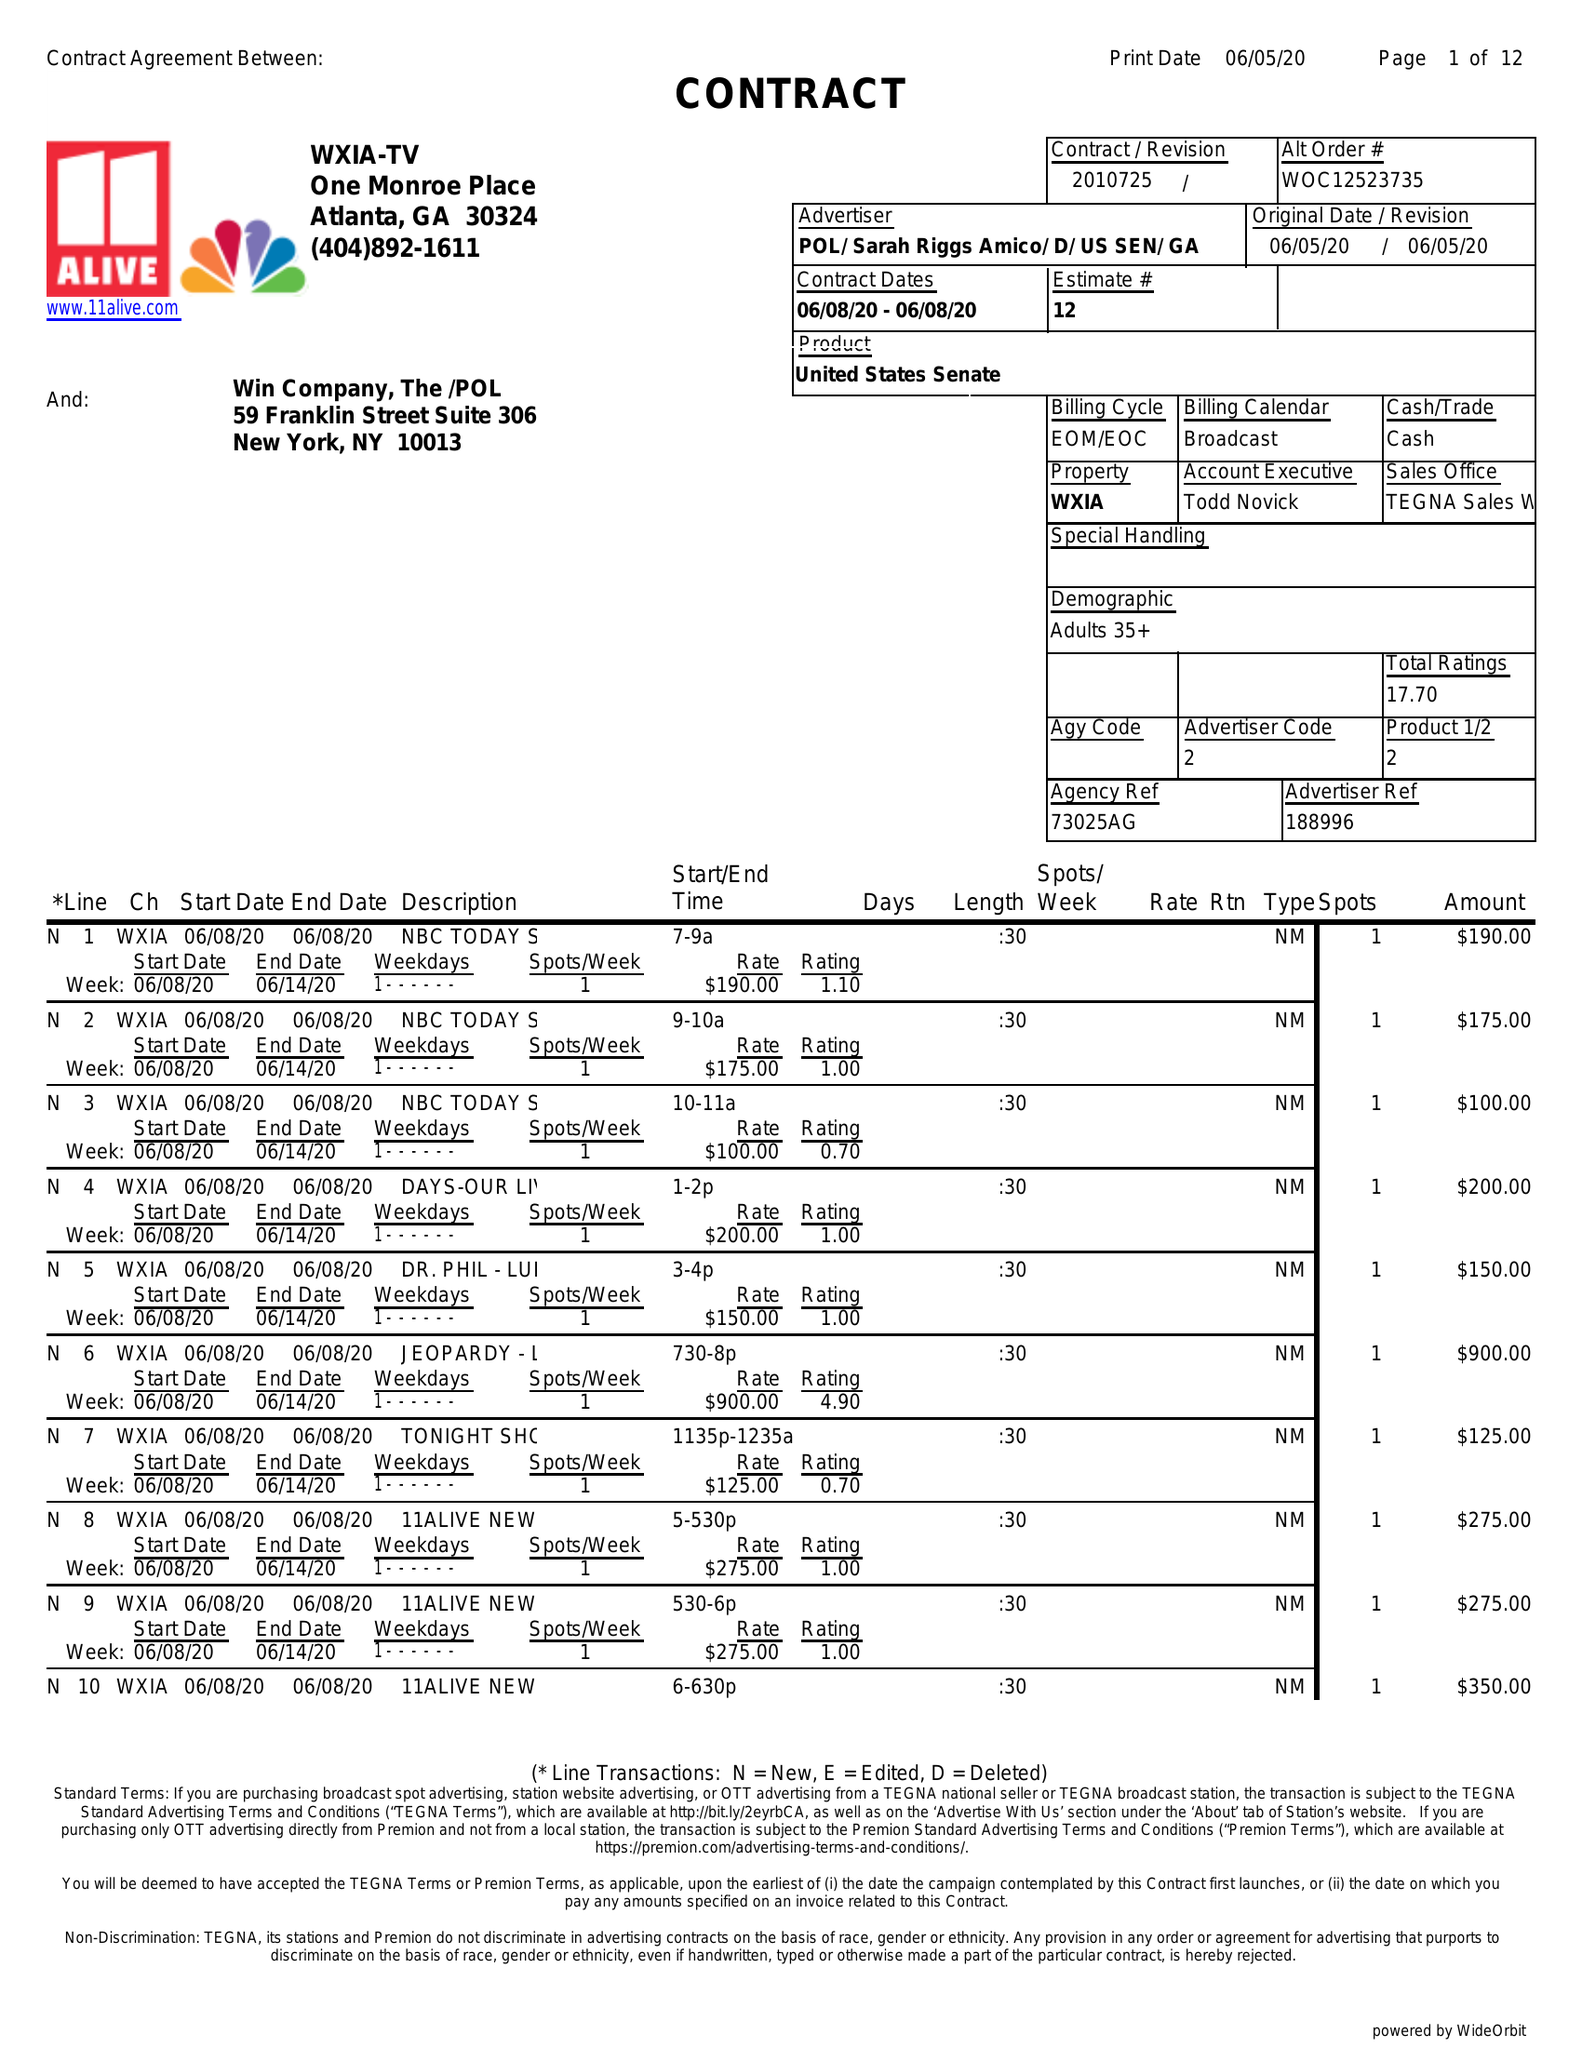What is the value for the flight_from?
Answer the question using a single word or phrase. 06/08/20 